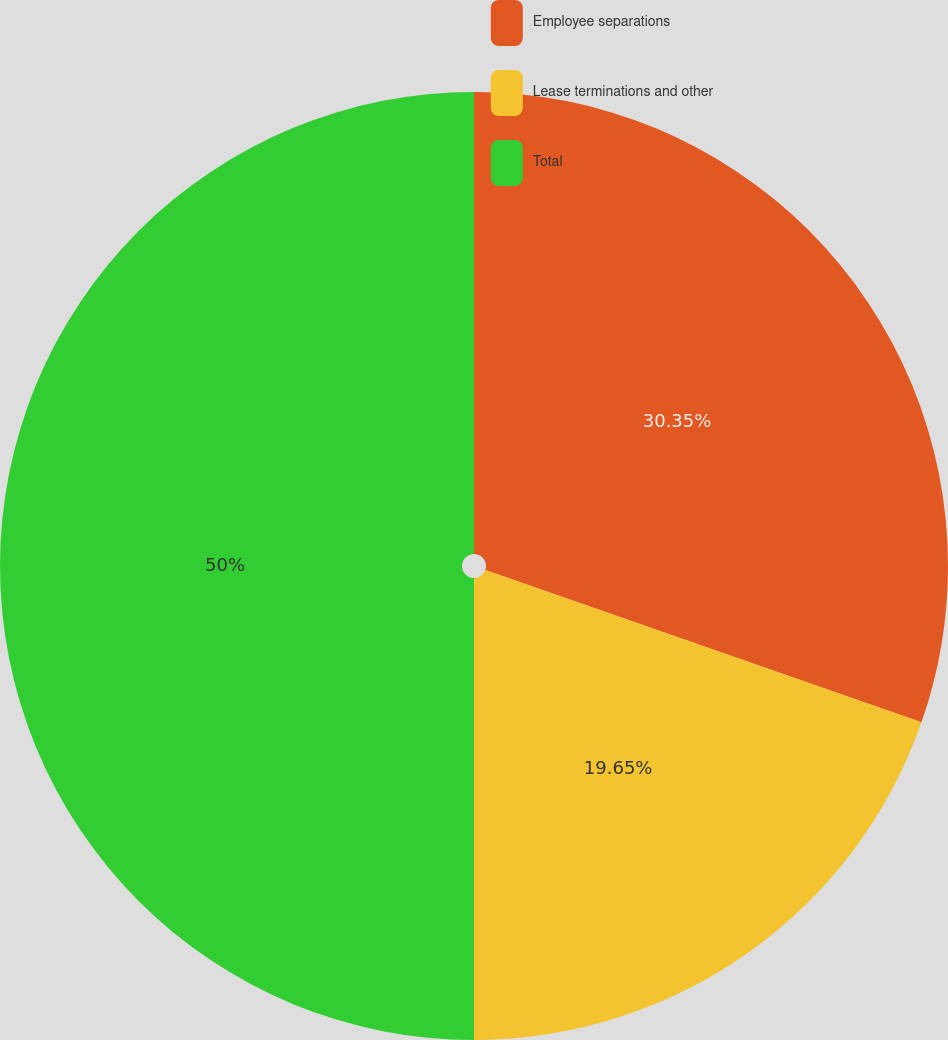Convert chart to OTSL. <chart><loc_0><loc_0><loc_500><loc_500><pie_chart><fcel>Employee separations<fcel>Lease terminations and other<fcel>Total<nl><fcel>30.35%<fcel>19.65%<fcel>50.0%<nl></chart> 